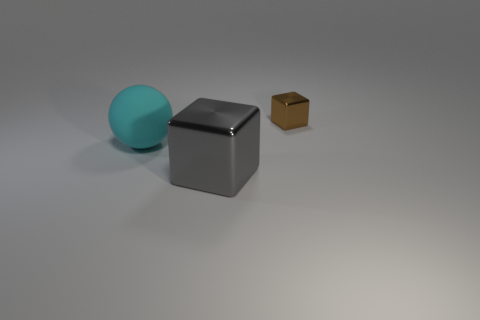How many spheres are cyan things or gray shiny objects?
Provide a short and direct response. 1. Is there a big brown object?
Provide a short and direct response. No. What size is the other brown shiny thing that is the same shape as the big metallic thing?
Give a very brief answer. Small. What is the shape of the cyan matte object in front of the shiny block behind the cyan ball?
Offer a very short reply. Sphere. What number of yellow objects are small blocks or cubes?
Make the answer very short. 0. What is the color of the tiny cube?
Your answer should be compact. Brown. Is the brown object the same size as the cyan matte thing?
Ensure brevity in your answer.  No. Is there anything else that is the same shape as the cyan matte object?
Ensure brevity in your answer.  No. Does the large gray object have the same material as the cube behind the large gray metal cube?
Give a very brief answer. Yes. What number of objects are both on the right side of the ball and behind the large gray metallic thing?
Provide a short and direct response. 1. 